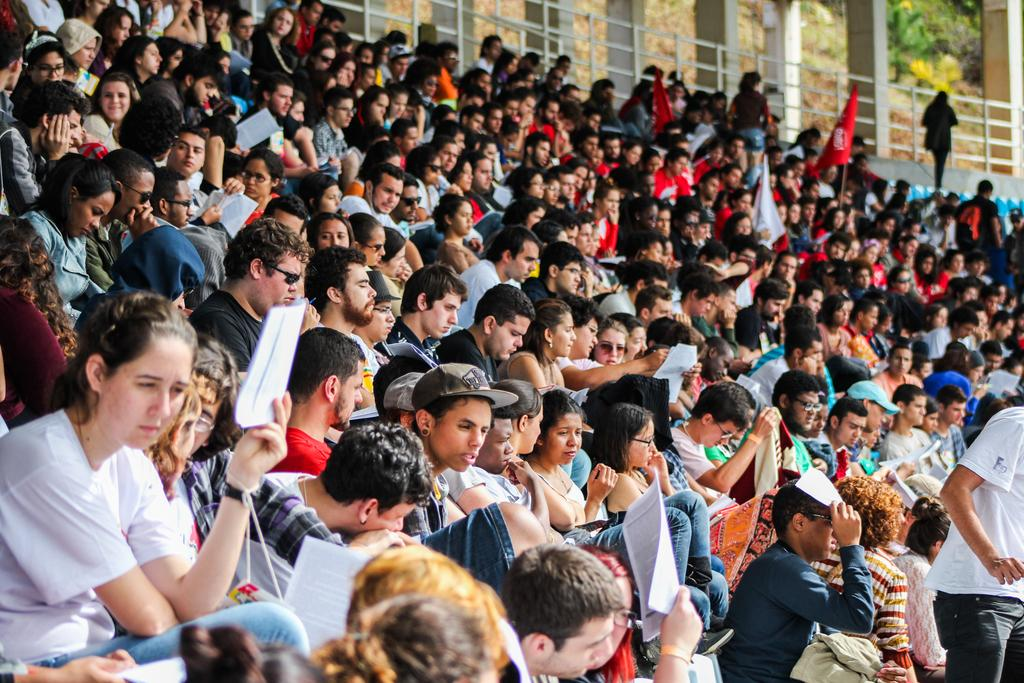How many people are in the image? There is a group of persons in the image. What are the persons in the image doing? The persons are sitting in a row. On what surface are the persons sitting? The persons are on a surface. What can be seen in the background of the image? There are trees in the background of the image. What type of structure is present in the image? There is fencing in the image. Can you tell me how many basketballs are visible in the image? There are no basketballs present in the image. What type of beam is supporting the persons in the image? There is no beam present in the image; the persons are sitting on a surface. 